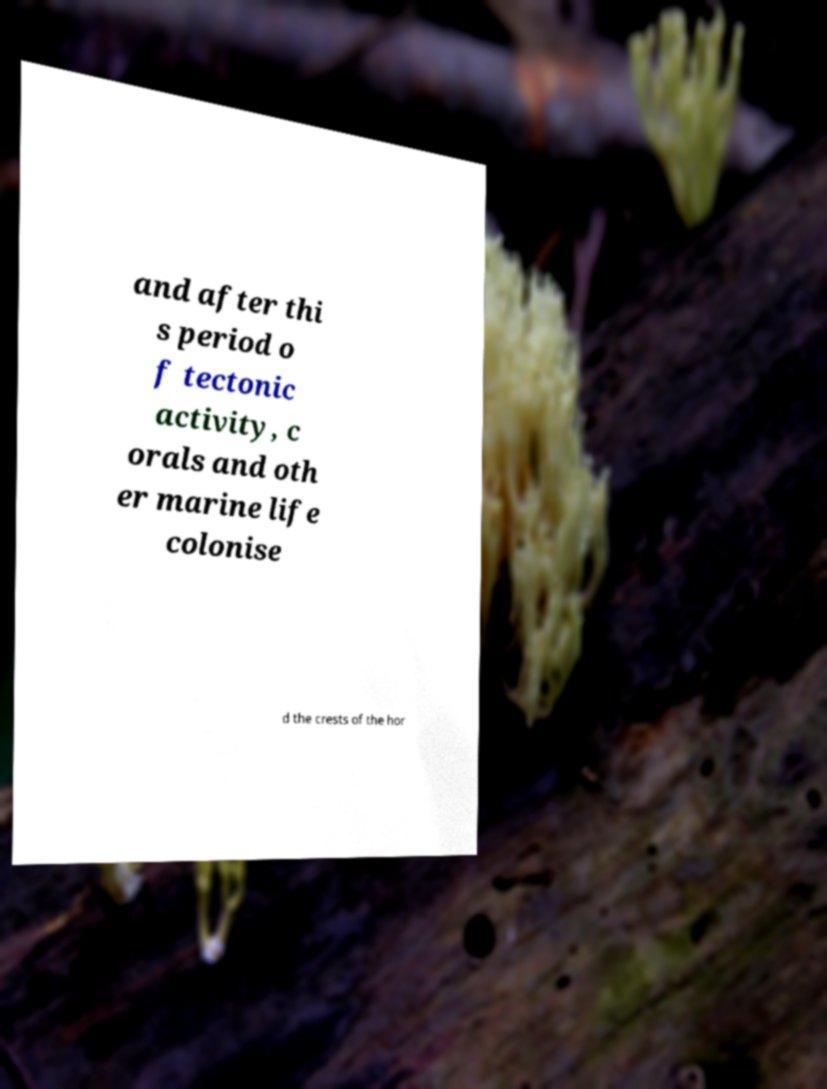Can you accurately transcribe the text from the provided image for me? and after thi s period o f tectonic activity, c orals and oth er marine life colonise d the crests of the hor 